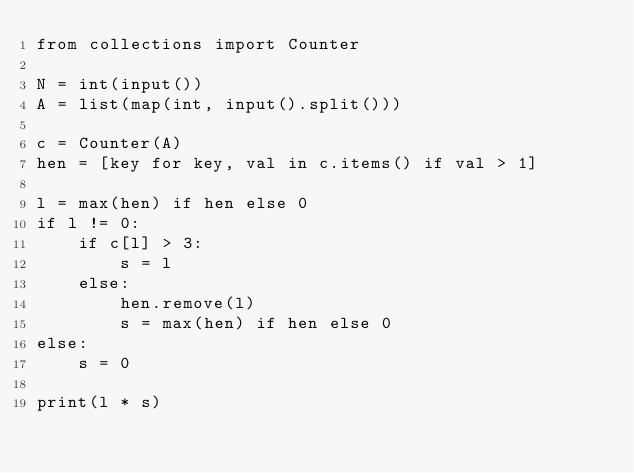Convert code to text. <code><loc_0><loc_0><loc_500><loc_500><_Python_>from collections import Counter

N = int(input())
A = list(map(int, input().split()))

c = Counter(A)
hen = [key for key, val in c.items() if val > 1]

l = max(hen) if hen else 0
if l != 0:
    if c[l] > 3:
        s = l
    else:
        hen.remove(l)
        s = max(hen) if hen else 0
else:
    s = 0

print(l * s)
</code> 